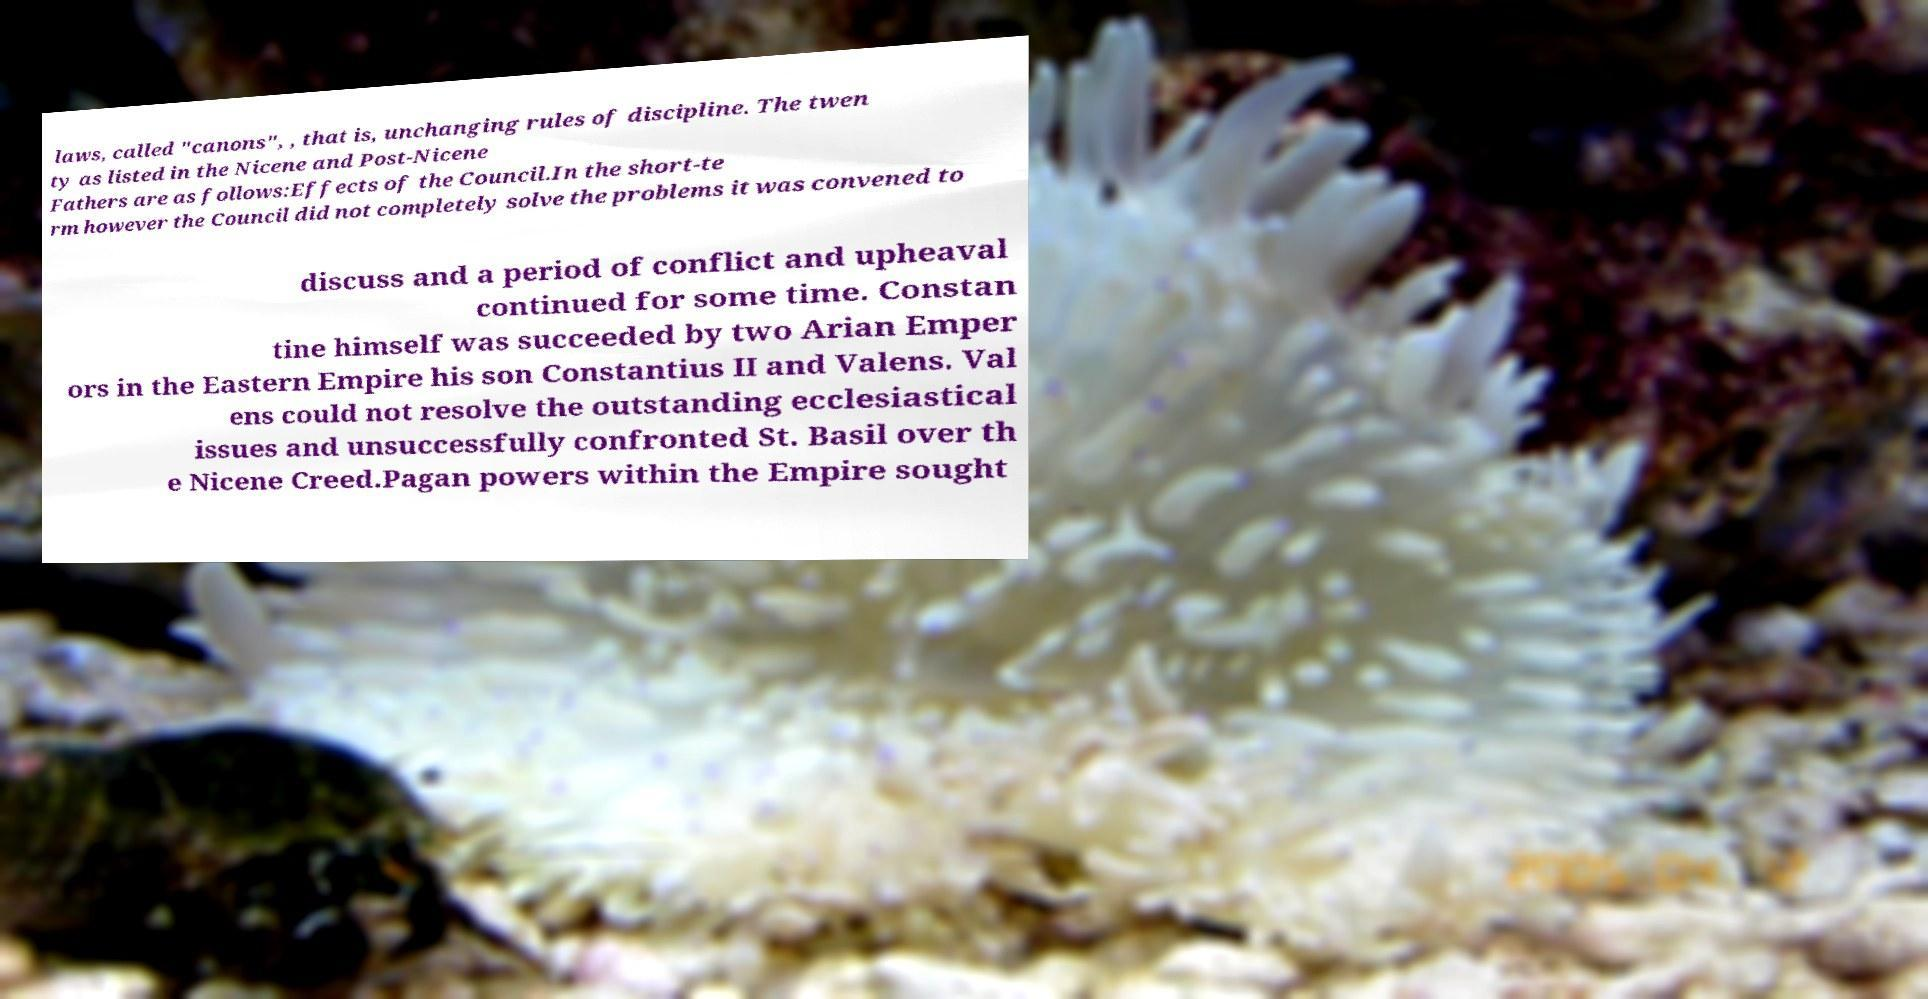Could you assist in decoding the text presented in this image and type it out clearly? laws, called "canons", , that is, unchanging rules of discipline. The twen ty as listed in the Nicene and Post-Nicene Fathers are as follows:Effects of the Council.In the short-te rm however the Council did not completely solve the problems it was convened to discuss and a period of conflict and upheaval continued for some time. Constan tine himself was succeeded by two Arian Emper ors in the Eastern Empire his son Constantius II and Valens. Val ens could not resolve the outstanding ecclesiastical issues and unsuccessfully confronted St. Basil over th e Nicene Creed.Pagan powers within the Empire sought 